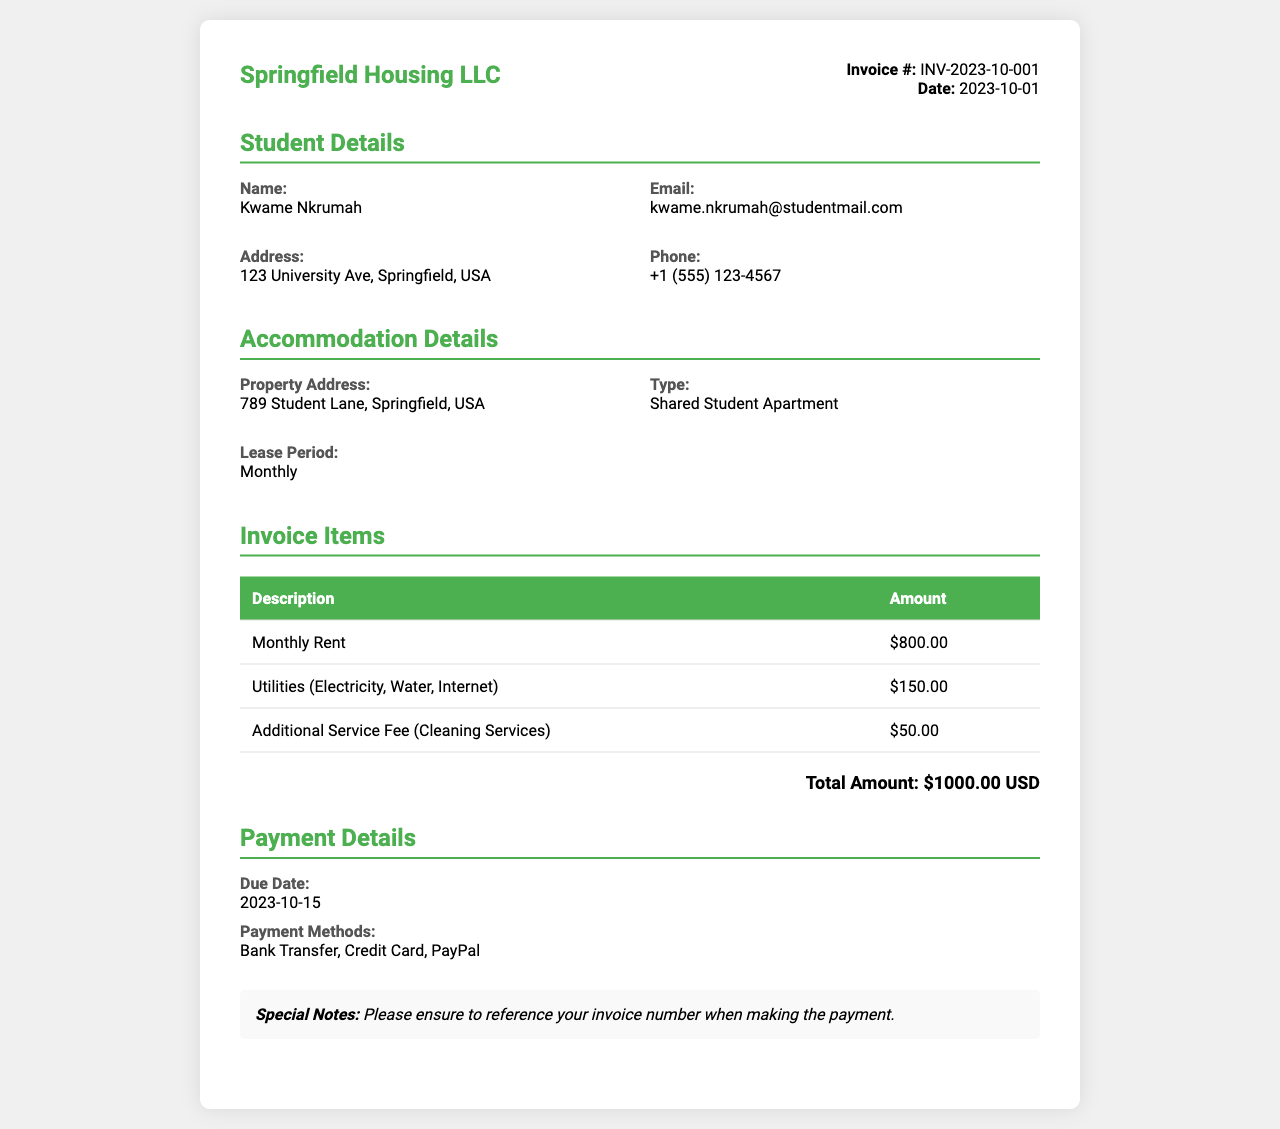What is the invoice number? The invoice number is listed in the document as a unique identifier, which is INV-2023-10-001.
Answer: INV-2023-10-001 Who is the student? The document specifies the name of the student, which is Kwame Nkrumah.
Answer: Kwame Nkrumah What is the total amount due? The total amount due is calculated based on the sum of all items listed in the invoice, which totals $1000.00 USD.
Answer: $1000.00 USD What is the due date for payment? The due date for payment is clearly stated in the document under payment details, which is 2023-10-15.
Answer: 2023-10-15 What is the type of accommodation? The document describes the type of accommodation being rented as a Shared Student Apartment.
Answer: Shared Student Apartment How much is the monthly rent? The monthly rent is explicitly mentioned in the invoice items section, which is $800.00.
Answer: $800.00 What utilities are included? The document states that the utilities included are Electricity, Water, and Internet.
Answer: Electricity, Water, Internet What payment methods are accepted? The document lists the payment methods accepted for this invoice as Bank Transfer, Credit Card, and PayPal.
Answer: Bank Transfer, Credit Card, PayPal 